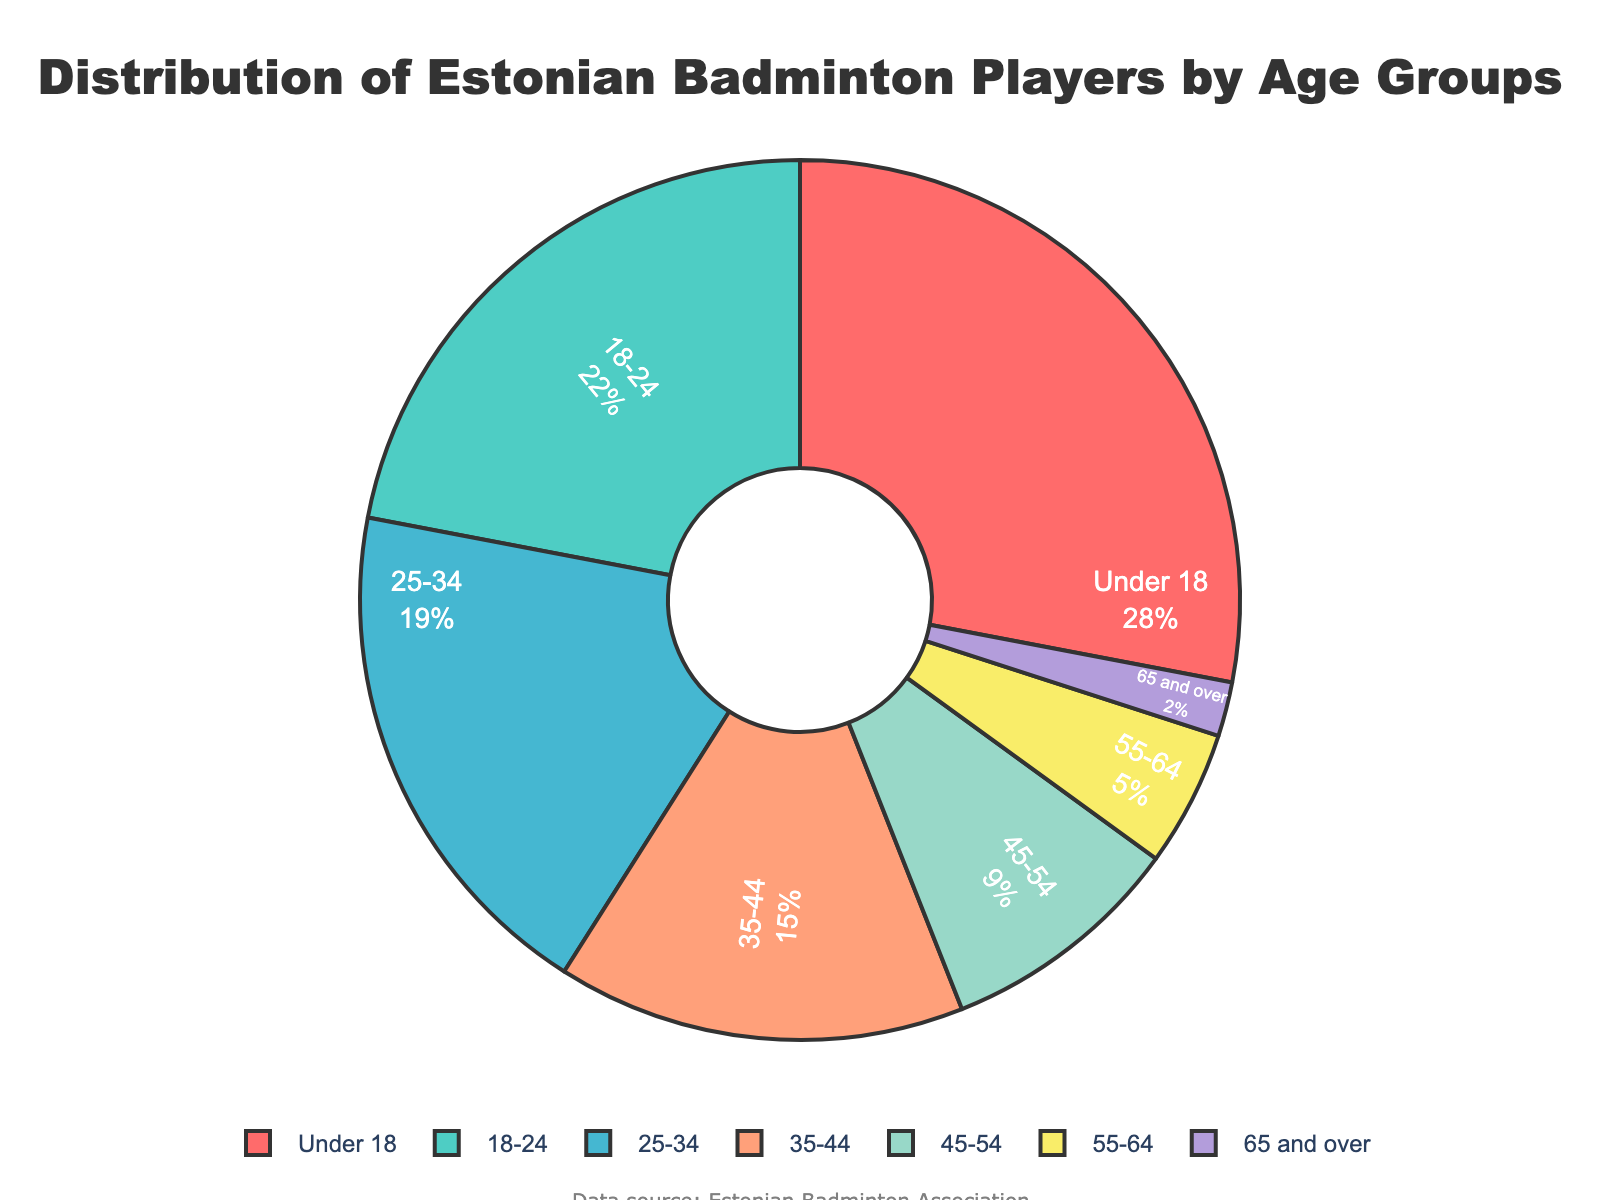What's the most common age group of Estonian badminton players? The pie chart shows that the "Under 18" age group has the largest percentage.
Answer: Under 18 Which two age groups combined make up just over half of the players? The "Under 18" group is 28% and the "18-24" group is 22%. Combined, they add up to 50%.
Answer: Under 18 and 18-24 What is the total percentage of players aged 45 and above? Add the percentages of the age groups "45-54" (9%), "55-64" (5%), and "65 and over" (2%). 9 + 5 + 2 = 16%.
Answer: 16% Is the "35-44" age group larger or smaller than the "25-34" age group? The "35-44" age group is 15% while the "25-34" age group is 19%. 15% is smaller than 19%.
Answer: Smaller What percentage of players are under the age of 35? Add the percentages of the age groups "Under 18" (28%), "18-24" (22%), and "25-34" (19%). 28 + 22 + 19 = 69%.
Answer: 69% Which age group is represented by the red color in the pie chart? The color of the largest segment (red) corresponds to the "Under 18" age group.
Answer: Under 18 How much larger is the "18-24" age group compared to the "55-64" age group? The "18-24" age group is 22% and the "55-64" age group is 5%. The difference is 22 - 5 = 17%.
Answer: 17% What is the range (difference between the largest and smallest percentages) of the age groups? The largest percentage is 28% ("Under 18") and the smallest is 2% ("65 and over"). The range is 28 - 2 = 26%.
Answer: 26% Which age group's slice in the pie chart would be the fifth largest? The "45-54" age group has the fifth largest percentage at 9%.
Answer: 45-54 How does the percentage of players aged "25-34" compare to the combined percentage of players aged "55 and over"? The "25-34" age group is 19%. Combined, the "55-64" (5%) and "65 and over" (2%) groups total 7%. Thus, 19% is significantly larger than 7%.
Answer: Larger 